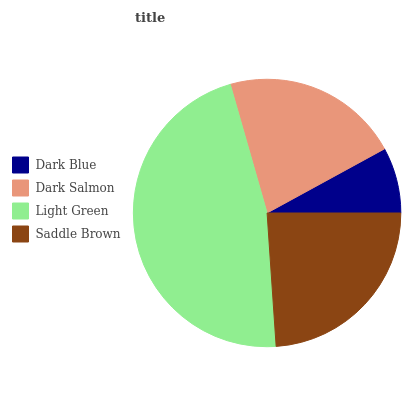Is Dark Blue the minimum?
Answer yes or no. Yes. Is Light Green the maximum?
Answer yes or no. Yes. Is Dark Salmon the minimum?
Answer yes or no. No. Is Dark Salmon the maximum?
Answer yes or no. No. Is Dark Salmon greater than Dark Blue?
Answer yes or no. Yes. Is Dark Blue less than Dark Salmon?
Answer yes or no. Yes. Is Dark Blue greater than Dark Salmon?
Answer yes or no. No. Is Dark Salmon less than Dark Blue?
Answer yes or no. No. Is Saddle Brown the high median?
Answer yes or no. Yes. Is Dark Salmon the low median?
Answer yes or no. Yes. Is Dark Salmon the high median?
Answer yes or no. No. Is Dark Blue the low median?
Answer yes or no. No. 